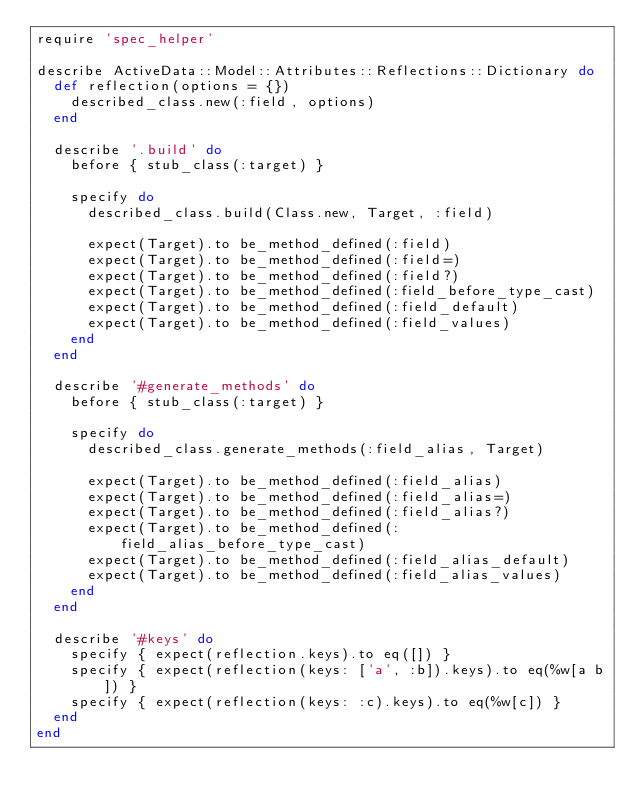<code> <loc_0><loc_0><loc_500><loc_500><_Ruby_>require 'spec_helper'

describe ActiveData::Model::Attributes::Reflections::Dictionary do
  def reflection(options = {})
    described_class.new(:field, options)
  end

  describe '.build' do
    before { stub_class(:target) }

    specify do
      described_class.build(Class.new, Target, :field)

      expect(Target).to be_method_defined(:field)
      expect(Target).to be_method_defined(:field=)
      expect(Target).to be_method_defined(:field?)
      expect(Target).to be_method_defined(:field_before_type_cast)
      expect(Target).to be_method_defined(:field_default)
      expect(Target).to be_method_defined(:field_values)
    end
  end

  describe '#generate_methods' do
    before { stub_class(:target) }

    specify do
      described_class.generate_methods(:field_alias, Target)

      expect(Target).to be_method_defined(:field_alias)
      expect(Target).to be_method_defined(:field_alias=)
      expect(Target).to be_method_defined(:field_alias?)
      expect(Target).to be_method_defined(:field_alias_before_type_cast)
      expect(Target).to be_method_defined(:field_alias_default)
      expect(Target).to be_method_defined(:field_alias_values)
    end
  end

  describe '#keys' do
    specify { expect(reflection.keys).to eq([]) }
    specify { expect(reflection(keys: ['a', :b]).keys).to eq(%w[a b]) }
    specify { expect(reflection(keys: :c).keys).to eq(%w[c]) }
  end
end
</code> 